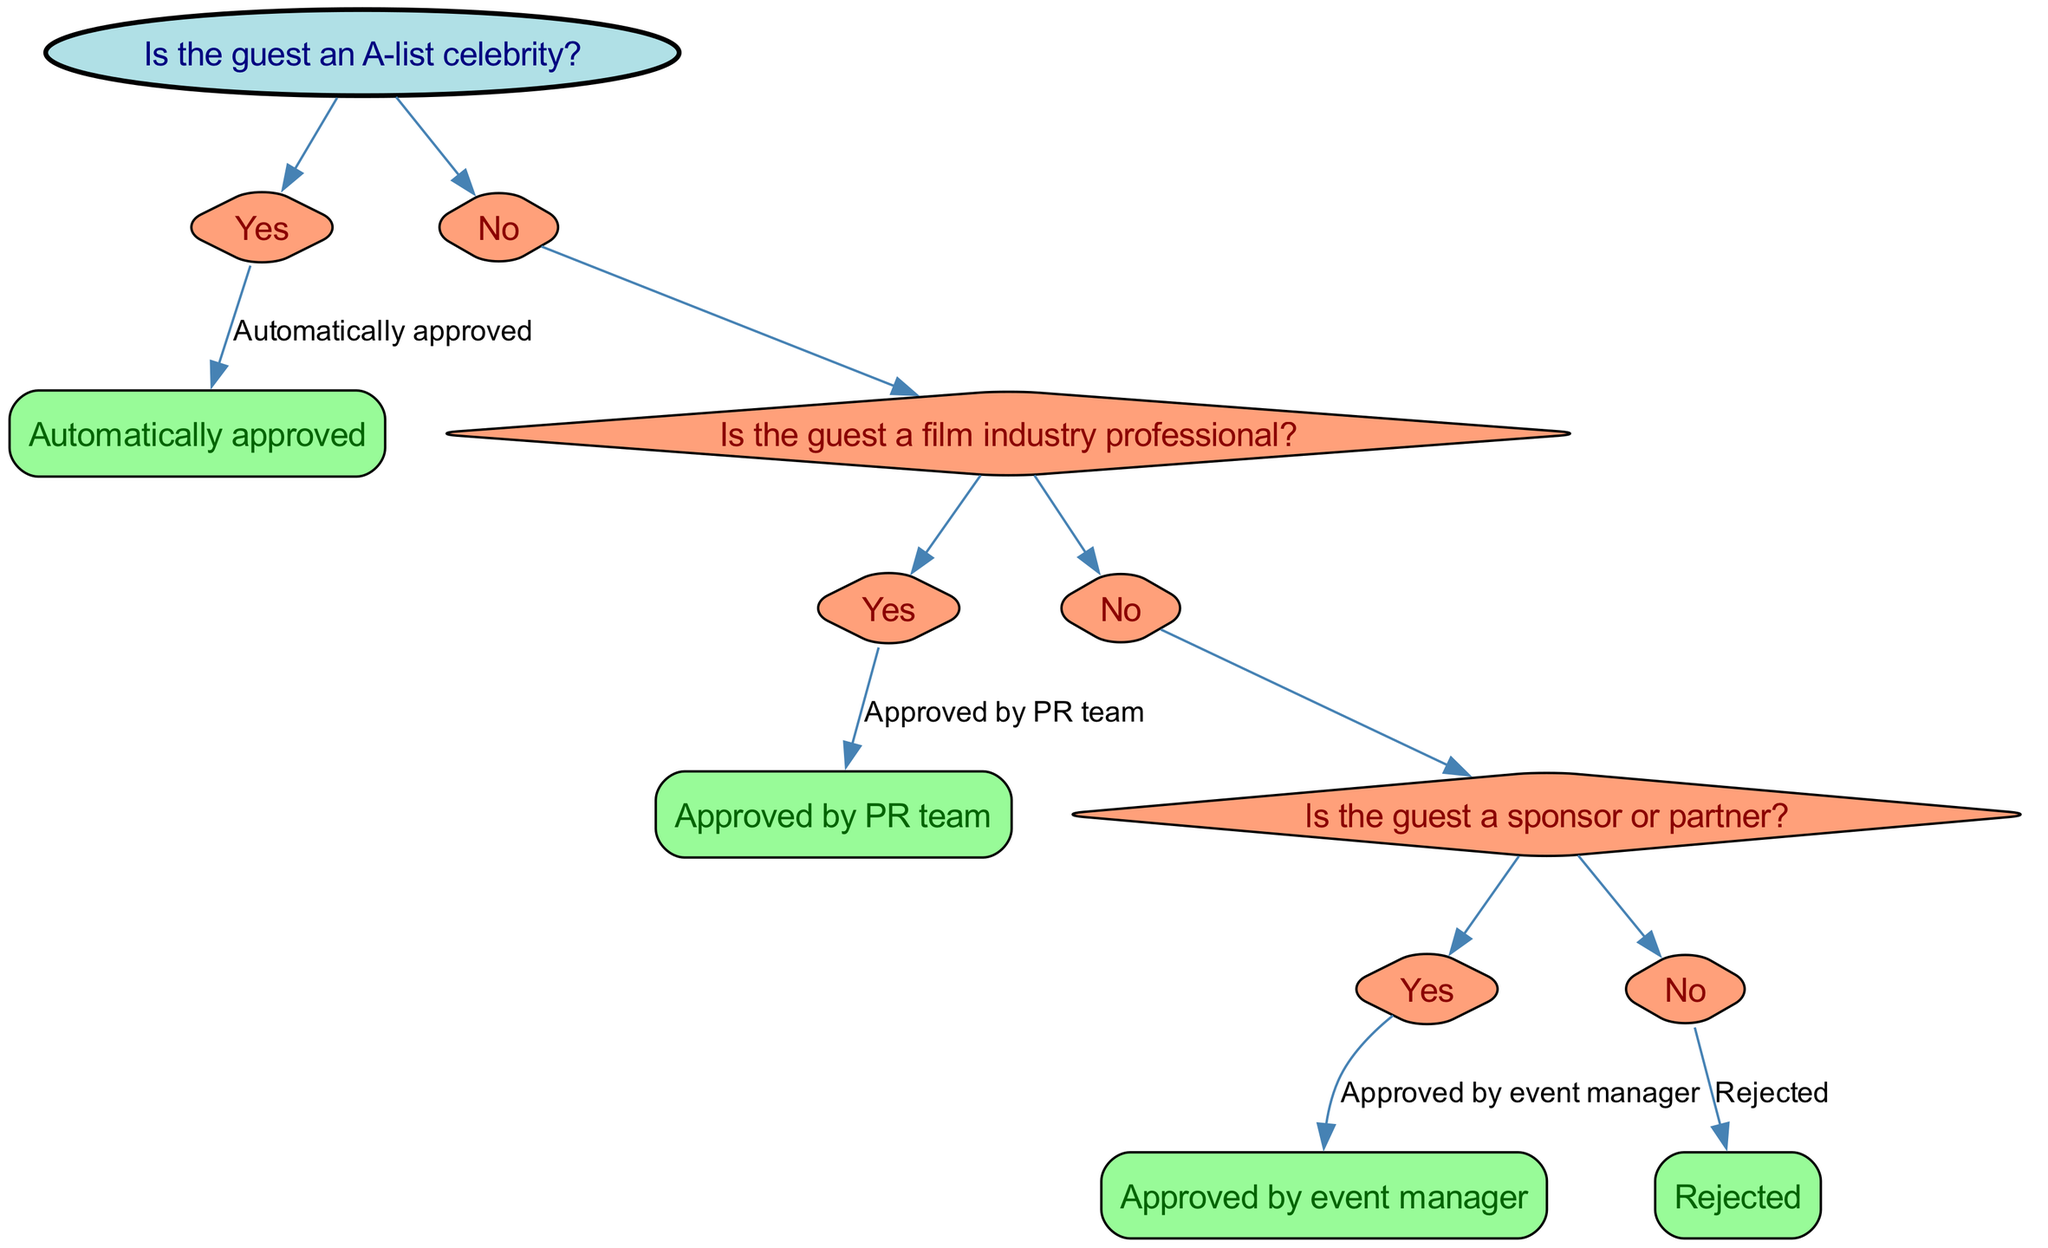What is the root node of the decision tree? The root node is labeled "VIP Guest List Approval," which serves as the starting point of the decision-making process in the diagram.
Answer: VIP Guest List Approval How many children does the first decision node have? The first decision node, which asks if the guest is an A-list celebrity, has two children: "Yes" and "No."
Answer: 2 What happens if the guest is an A-list celebrity? If the guest is identified as an A-list celebrity, the next step indicated is "Automatically approved," meaning they do not require further evaluation.
Answer: Automatically approved Who approves the guest if they are a film industry professional? If the guest is confirmed to be a film industry professional, they are "Approved by PR team," illustrating that the PR team handles the approval in this case.
Answer: Approved by PR team What is the outcome if the guest is neither an A-list celebrity nor a film industry professional? If the guest does not qualify as either an A-list celebrity or a film industry professional, the decision tree directs to a question about their status as a sponsor or partner. If they are not, the outcome would be "Rejected."
Answer: Rejected What follows if the guest qualifies as a sponsor or partner? For a guest categorized as a sponsor or partner, the decision tree indicates that they would be "Approved by event manager," showing that this approval falls under the event management category.
Answer: Approved by event manager How many total approval outcomes are there in the decision tree? The decision tree concludes with two distinct approval outcomes: "Automatically approved" and "Approved by PR team," plus the "Approved by event manager," leading to a total of three approval outcomes.
Answer: 3 What type of node represents "Is the guest a sponsor or partner?" The node "Is the guest a sponsor or partner?" is a decision node, which is represented in the diagram as a diamond shape, denoting that it requires an answer to proceed further.
Answer: Decision node What will happen if a guest is not a film industry professional and not a sponsor? If a guest is found to be neither a film industry professional nor a sponsor, they will follow the path leading to the outcome of "Rejected," indicating they are not approved to attend the event.
Answer: Rejected 